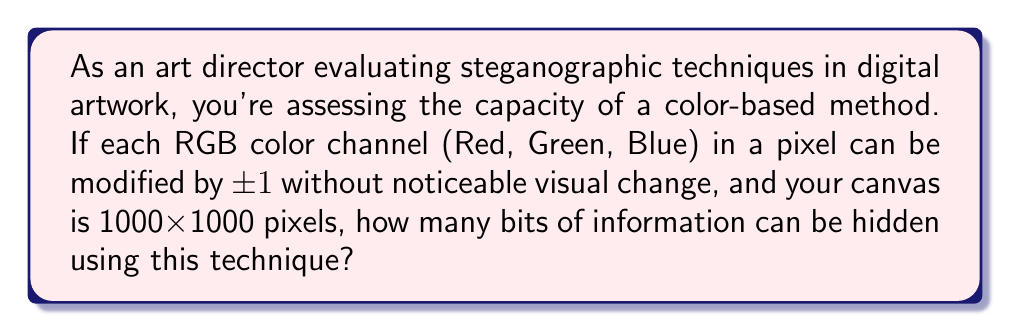Provide a solution to this math problem. Let's approach this step-by-step:

1) First, we need to understand what the question is asking:
   - We can modify each color channel (R, G, B) by ±1
   - The canvas size is 1000x1000 pixels

2) For each pixel:
   - We have 3 color channels (R, G, B)
   - Each channel can be modified, allowing us to encode 1 bit per channel

3) So, for each pixel, we can encode 3 bits of information

4) Now, let's calculate the total number of pixels:
   $$1000 \times 1000 = 1,000,000 \text{ pixels}$$

5) For the entire canvas, the total number of bits we can encode is:
   $$1,000,000 \text{ pixels} \times 3 \text{ bits/pixel} = 3,000,000 \text{ bits}$$

6) To convert bits to bytes, we divide by 8:
   $$\frac{3,000,000 \text{ bits}}{8 \text{ bits/byte}} = 375,000 \text{ bytes}$$

7) To convert bytes to kilobytes, we divide by 1024:
   $$\frac{375,000 \text{ bytes}}{1024 \text{ bytes/KB}} \approx 366.21 \text{ KB}$$

Therefore, using this steganographic technique, approximately 366.21 KB of information can be hidden in the digital artwork.
Answer: 366.21 KB 